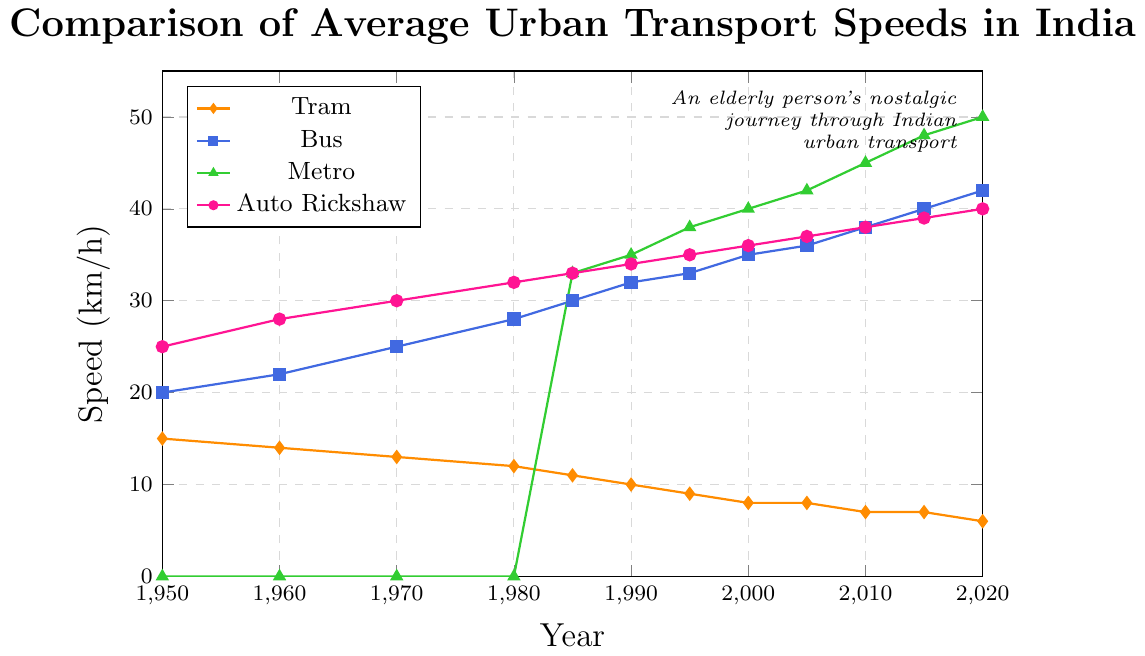What's the average speed of trams throughout the decades? Look at the speeds of trams from 1950 to 2020, sum them up and divide by the number of data points. (15+14+13+12+11+10+9+8+8+7+7+6) = 120, then divide by 12, giving 10 km/h
Answer: 10 km/h In which year do buses surpass the speed of auto-rickshaws? Compare the speeds of buses and auto-rickshaws from each year. The first year where the bus speed is greater is 1990.
Answer: 1990 In 1985, which mode of transport had the fastest average speed? Look at the speeds in 1985: Tram (11 km/h), Bus (30 km/h), Metro (33 km/h), Auto Rickshaw (33 km/h). Metro and Auto Rickshaw have similar speeds, both being the highest.
Answer: Metro and Auto Rickshaw What was the average increase in speed for buses every decade between 1950 and 2020? Calculate the differences in bus speeds at the start and end of each decade and then average these differences: ((22-20)+(25-22)+(28-25)+(30-28)+(32-30)+(33-32)+(35-33)+(36-35)+(38-36)+(40-38)+(42-40)) = 22, then 22/11 ≈ 2 km/h per decade.
Answer: 2 km/h per decade Which mode of transport consistently decreased in speed over the years? Identify the trend by plotting the data of each mode of transport and see which one consistently goes down. This is only true for the trams.
Answer: Trams By how much did the speed of the metro increase from its introduction in 1985 to 2020? Look at the speed of the metro in both years: 1985 (33 km/h) and 2020 (50 km/h). The increase is 50 - 33 = 17 km/h.
Answer: 17 km/h How does the speed of trams in 1950 compare to the speed of buses in 2020? Compare the values directly, tram speed in 1950 is 15 km/h and bus speed in 2020 is 42 km/h, so buses are significantly faster.
Answer: Bus speed is much faster From 1950 to 2020, which mode of transport showed the least variation in speed? Calculate the range of speeds for each transport mode from 1950 to 2020: Tram (15-6 = 9 km/h), Bus (42-20 = 22 km/h), Metro (50-33 = 17 km/h), Auto Rickshaw (40-25 = 15 km/h). Trams show the least variation.
Answer: Trams In which decade did auto-rickshaws experience the highest increase in speed? Check the speed differences for each decade and find the maximum: (28-25=3), (30-28=2), (32-30=2), (33-32=1), (34-33=1), (35-34=1), (36-35=1), (37-36=1), (38-37=1), (39-38=1), (40-39=1). The highest increase is 3 km/h in the 1950-1960 decade.
Answer: 1950-1960 